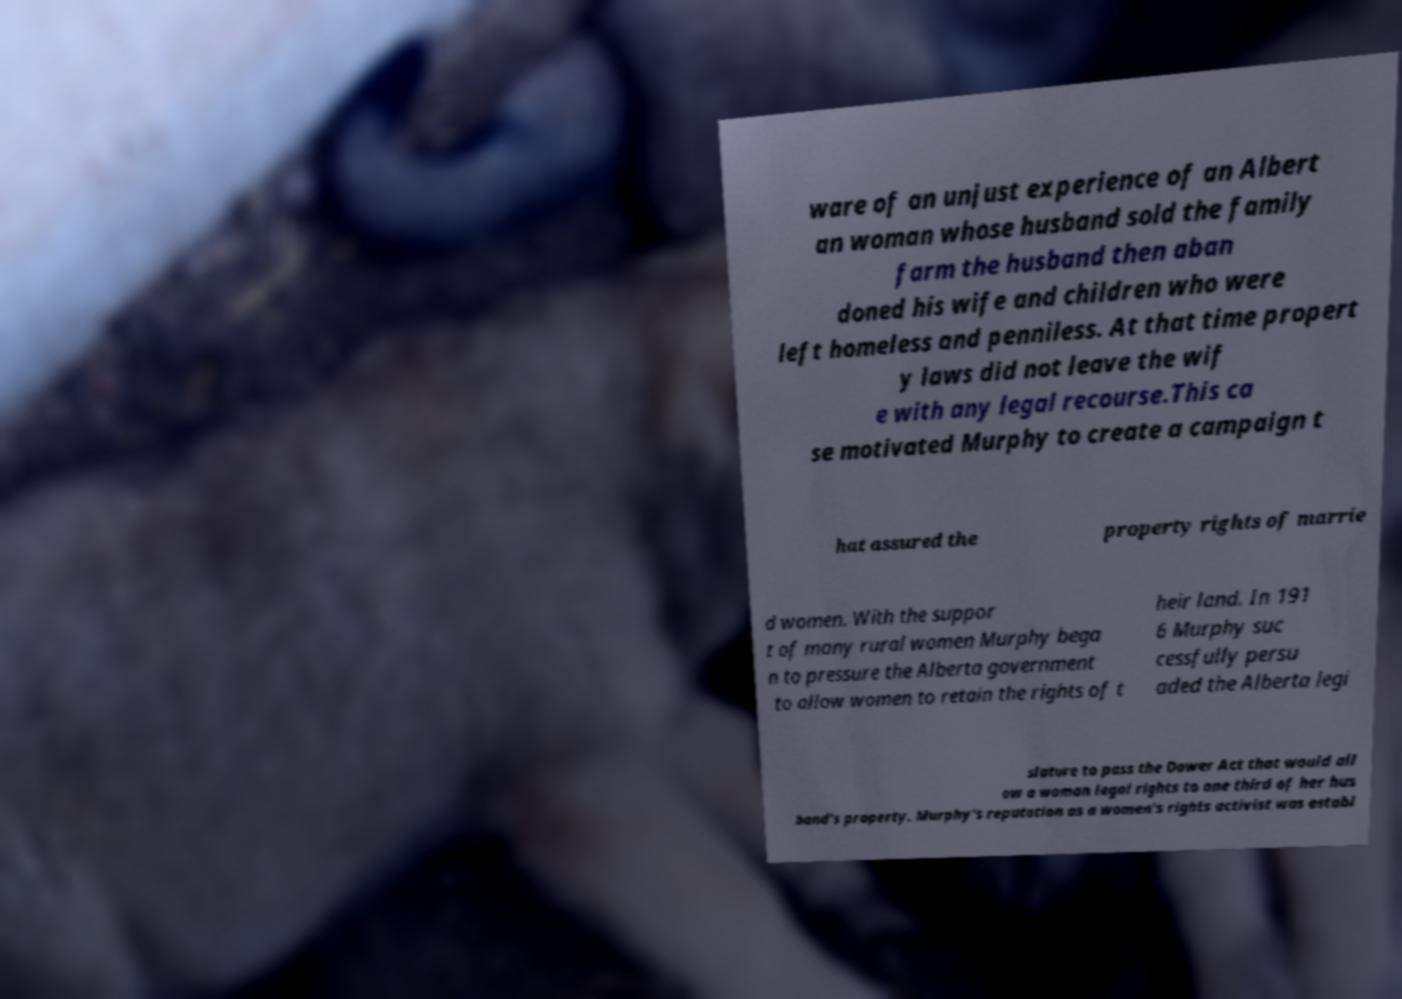There's text embedded in this image that I need extracted. Can you transcribe it verbatim? ware of an unjust experience of an Albert an woman whose husband sold the family farm the husband then aban doned his wife and children who were left homeless and penniless. At that time propert y laws did not leave the wif e with any legal recourse.This ca se motivated Murphy to create a campaign t hat assured the property rights of marrie d women. With the suppor t of many rural women Murphy bega n to pressure the Alberta government to allow women to retain the rights of t heir land. In 191 6 Murphy suc cessfully persu aded the Alberta legi slature to pass the Dower Act that would all ow a woman legal rights to one third of her hus band's property. Murphy's reputation as a women's rights activist was establ 